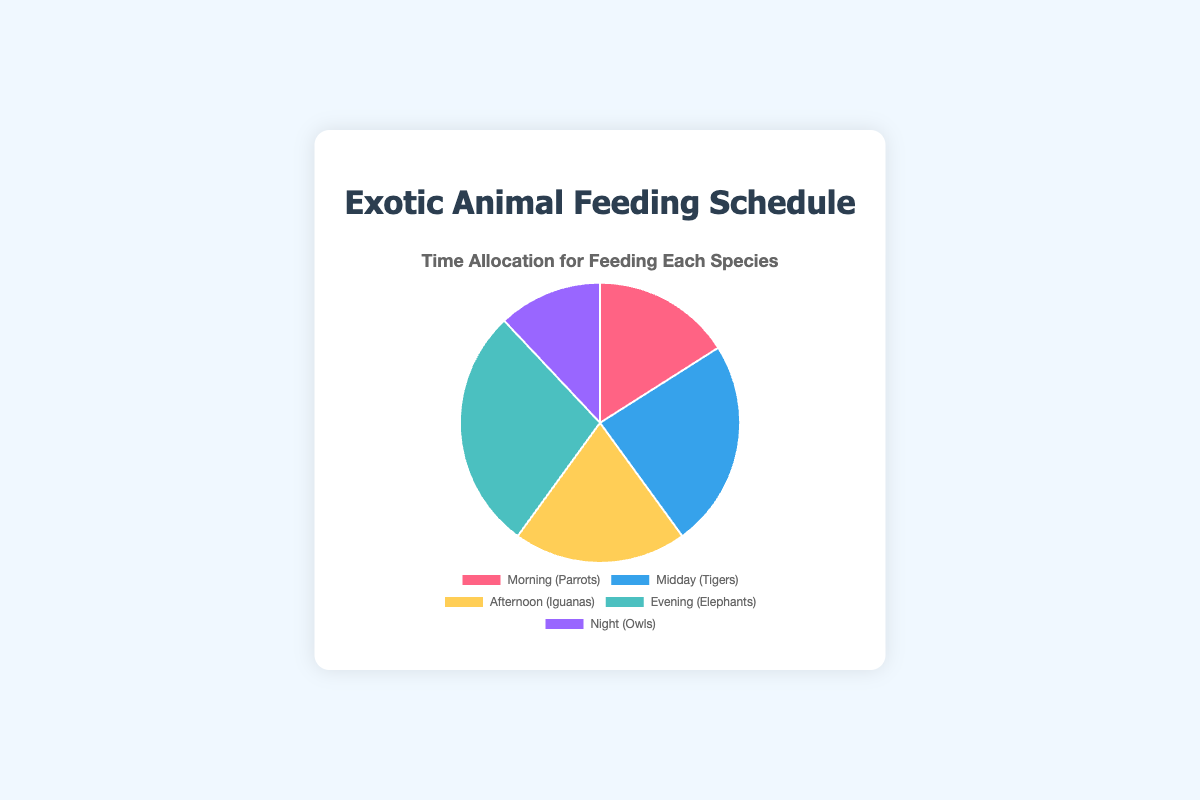What's the total amount of time allocated for feeding all species? Add the feeding durations for each time period: Morning (20) + Midday (30) + Afternoon (25) + Evening (35) + Night (15). So, 20 + 30 + 25 + 35 + 15 = 125 minutes.
Answer: 125 minutes Which species receives the most feeding time? Look for the largest segment in the pie chart with the highest feeding duration value: Evening (Elephants), which has 35 minutes.
Answer: Elephants Which species receives the least feeding time? Identify the smallest segment in the pie chart with the lowest feeding duration value: Night (Owls), which has 15 minutes.
Answer: Owls How does the feeding time for Tigers (Midday) compare to that of Iguanas (Afternoon)? Compare the feeding duration of Tigers (30 minutes) with that of Iguanas (25 minutes). Since 30 > 25, Tigers receive more feeding time.
Answer: Tigers receive more feeding time than Iguanas What is the average feeding time across all species? Calculate the average by summing all feeding times and dividing by the number of species: (20 + 30 + 25 + 35 + 15) / 5 = 125 / 5 = 25 minutes.
Answer: 25 minutes How does the feeding time for Parrots (Morning) compare to Elephants (Evening)? Compare the feeding duration of Parrots (20 minutes) with that of Elephants (35 minutes). Since 20 < 35, Parrots receive less feeding time.
Answer: Parrots receive less feeding time than Elephants Which two species combined have a total feeding time of 50 minutes? Look for two segments whose feeding durations sum up to 50: Morning (Parrots) and Afternoon (Iguanas). 20 + 25 = 45, not enough. Midday (Tigers) and Night (Owls): 30 + 15 = 45, not enough. Morning (Parrots) and Night (Owls): 20 + 15 = 35, not enough. Finally, Afternoon (Iguanas) and Night (Owls): 25 + 15 = 40, not enough. Therefore, no two species combine to 50 minutes.
Answer: None What is the difference in feeding time between the species fed in the Evening and the species fed in the Night? Subtract the feeding duration of Night (Owls) from Evening (Elephants): 35 - 15 = 20 minutes.
Answer: 20 minutes What fraction of the total feeding time is allocated to Tigers? Divide the feeding time of Tigers (30 minutes) by the total feeding time (125 minutes): 30 / 125 = 0.24. So, Tigers get 24% of the total feeding time.
Answer: 0.24 or 24% 